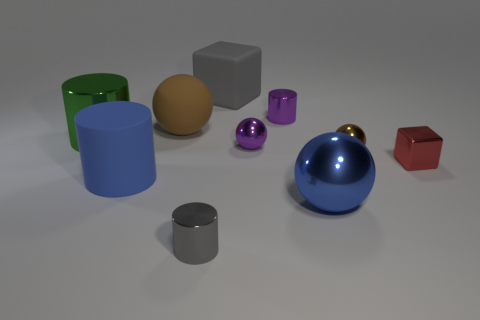Is there any other thing that is the same color as the large matte ball?
Your answer should be compact. Yes. There is a metal object to the left of the rubber thing that is in front of the brown ball to the left of the purple metallic sphere; what shape is it?
Your answer should be compact. Cylinder. Do the block on the right side of the large blue metallic object and the gray object that is left of the large cube have the same size?
Your response must be concise. Yes. How many large green objects have the same material as the gray cube?
Keep it short and to the point. 0. How many big blue cylinders are to the right of the small cylinder in front of the ball that is right of the large blue sphere?
Your response must be concise. 0. Is the shape of the blue shiny object the same as the big green metal thing?
Give a very brief answer. No. Is there a big green shiny thing that has the same shape as the gray shiny thing?
Keep it short and to the point. Yes. What shape is the gray thing that is the same size as the red metallic thing?
Provide a short and direct response. Cylinder. What material is the brown ball on the right side of the tiny metallic cylinder to the left of the tiny cylinder behind the brown matte sphere?
Your response must be concise. Metal. Is the size of the blue metal thing the same as the purple shiny sphere?
Keep it short and to the point. No. 